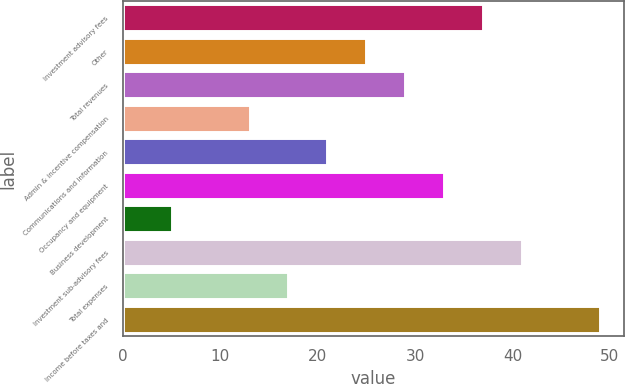Convert chart to OTSL. <chart><loc_0><loc_0><loc_500><loc_500><bar_chart><fcel>Investment advisory fees<fcel>Other<fcel>Total revenues<fcel>Admin & incentive compensation<fcel>Communications and information<fcel>Occupancy and equipment<fcel>Business development<fcel>Investment sub-advisory fees<fcel>Total expenses<fcel>Income before taxes and<nl><fcel>37<fcel>25<fcel>29<fcel>13<fcel>21<fcel>33<fcel>5<fcel>41<fcel>17<fcel>49<nl></chart> 